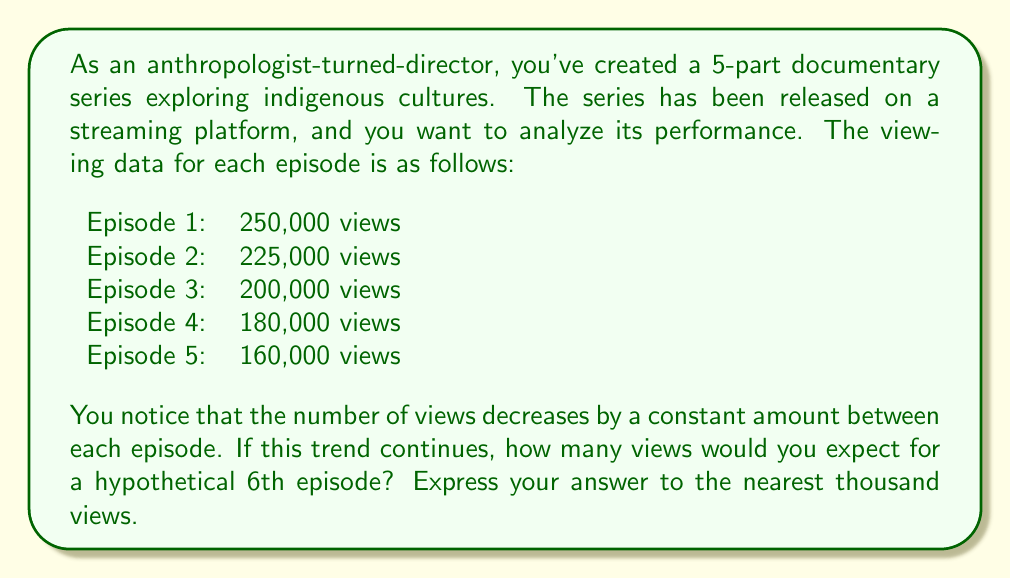Could you help me with this problem? To solve this problem, we need to follow these steps:

1. Determine the constant decrease in views between episodes:
   Let's call this decrease $d$.
   $d = 250,000 - 225,000 = 225,000 - 200,000 = 200,000 - 180,000 = 180,000 - 160,000 = 25,000$

2. We can represent this sequence as an arithmetic sequence with:
   $a_1 = 250,000$ (first term)
   $d = -25,000$ (common difference, negative because it's decreasing)

3. The formula for the nth term of an arithmetic sequence is:
   $a_n = a_1 + (n-1)d$

4. We want to find $a_6$, so we plug in $n=6$:
   $a_6 = 250,000 + (6-1)(-25,000)$
   $a_6 = 250,000 + 5(-25,000)$
   $a_6 = 250,000 - 125,000$
   $a_6 = 125,000$

5. Rounding to the nearest thousand:
   125,000 rounded to the nearest thousand is 125,000.

Therefore, if the trend continues, we would expect the 6th episode to have approximately 125,000 views.
Answer: 125,000 views 